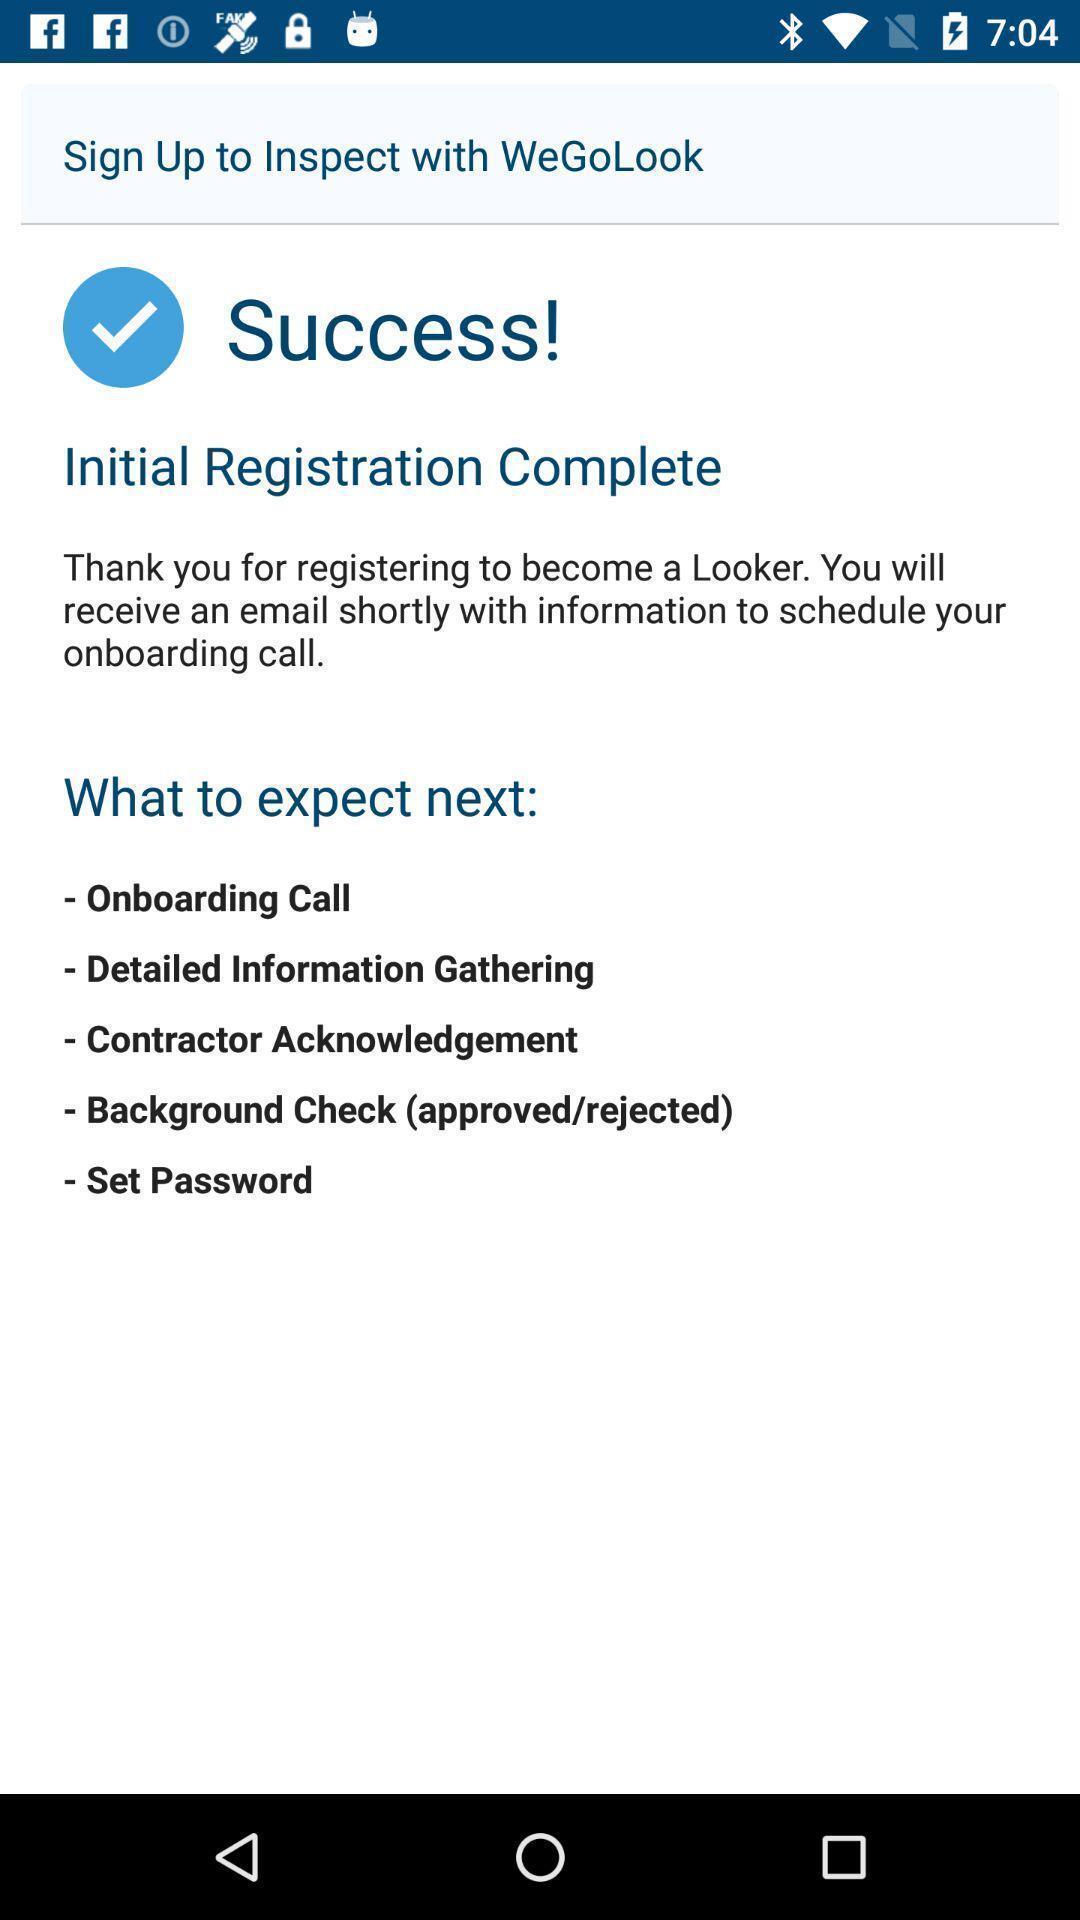Give me a narrative description of this picture. Screen showing registration complete page. 